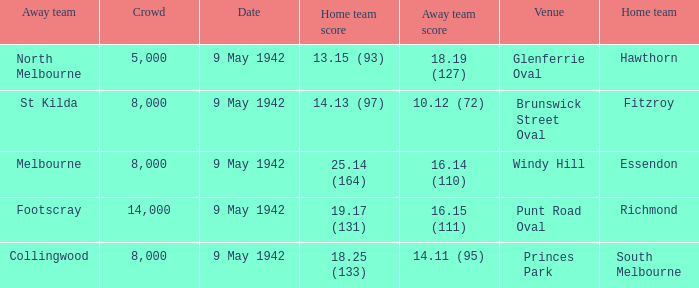How many people attended the game where Footscray was away? 14000.0. Parse the table in full. {'header': ['Away team', 'Crowd', 'Date', 'Home team score', 'Away team score', 'Venue', 'Home team'], 'rows': [['North Melbourne', '5,000', '9 May 1942', '13.15 (93)', '18.19 (127)', 'Glenferrie Oval', 'Hawthorn'], ['St Kilda', '8,000', '9 May 1942', '14.13 (97)', '10.12 (72)', 'Brunswick Street Oval', 'Fitzroy'], ['Melbourne', '8,000', '9 May 1942', '25.14 (164)', '16.14 (110)', 'Windy Hill', 'Essendon'], ['Footscray', '14,000', '9 May 1942', '19.17 (131)', '16.15 (111)', 'Punt Road Oval', 'Richmond'], ['Collingwood', '8,000', '9 May 1942', '18.25 (133)', '14.11 (95)', 'Princes Park', 'South Melbourne']]} 